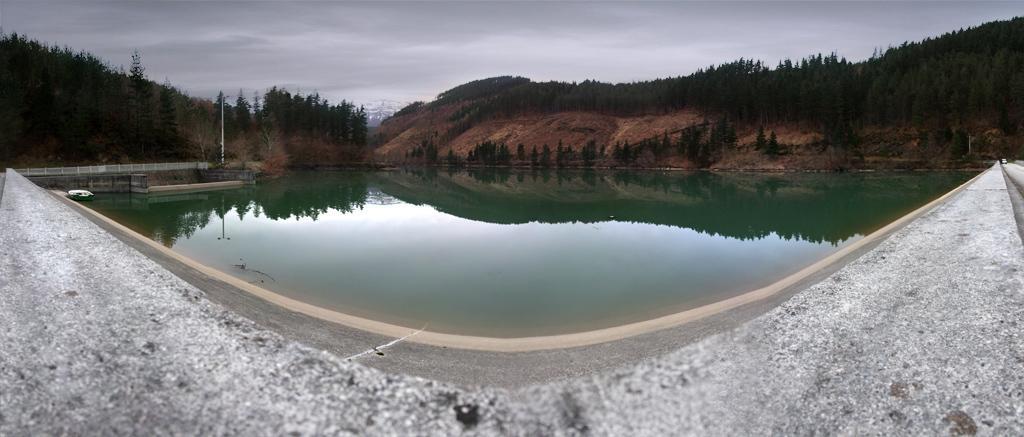Please provide a concise description of this image. In the picture I can see the surface of the wall, I can see the water, hills, pole, trees and the cloudy sky in the background. 